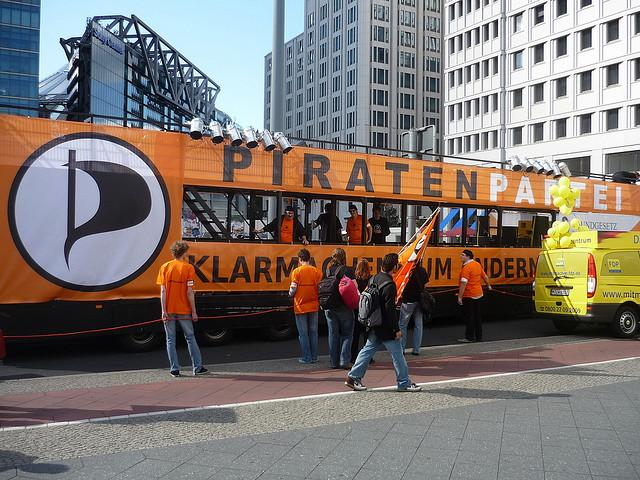Why are the people wearing orange shirts?

Choices:
A) costume
B) warmth
C) fashion
D) uniform uniform 